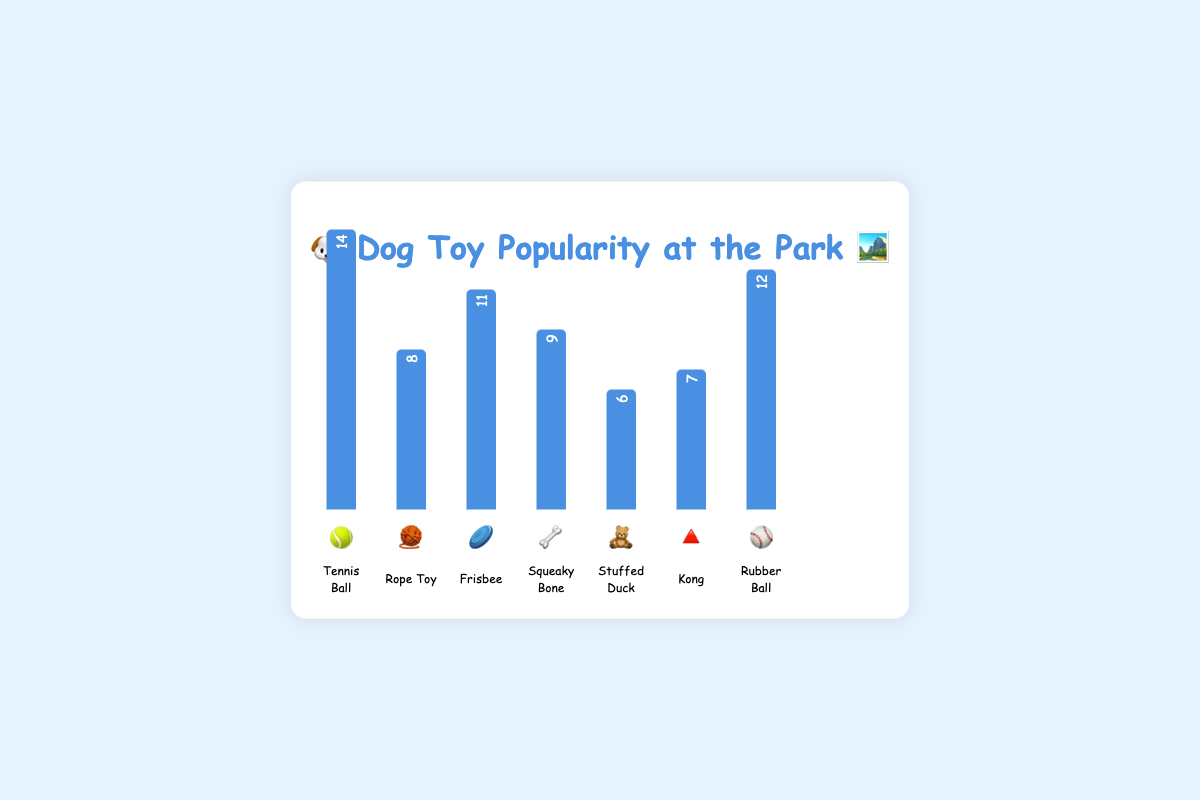What's the title of the chart? The title of the chart is mentioned at the top of the figure, styled prominently in Comic Sans MS font.
Answer: 🐶 Dog Toy Popularity at the Park 🏞️ Which toy is the most popular? The most popular toy is determined by the toy with the highest bar height and label value. The Tennis Ball has the highest count of 14.
Answer: Tennis Ball 🎾 How many Rubber Balls were brought to the park? Look at the height of the bar associated with the Rubber Ball and the label on the bar. The Rubber Ball has a count of 12.
Answer: 12 ⚾ Which toy has a higher count: Squeaky Bone or Kong? Compare the heights and the labels of the bars for Squeaky Bone and Kong. Squeaky Bone has a count of 9, and Kong has a count of 7.
Answer: Squeaky Bone 🦴 What is the combined count of the Rope Toy and Stuffed Duck? Add the counts of Rope Toy (8) and Stuffed Duck (6) to get the combined total.
Answer: 14 Rank the toys from the most popular to the least popular. Order the toys based on their counts from highest to lowest by examining each bar's height and label.
1. Tennis Ball (14)
2. Rubber Ball (12)
3. Frisbee (11)
4. Squeaky Bone (9)
5. Rope Toy (8)
6. Kong (7)
7. Stuffed Duck (6)
Answer: Tennis Ball 🎾, Rubber Ball ⚾, Frisbee 🥏, Squeaky Bone 🦴, Rope Toy 🧶, Kong 🔺, Stuffed Duck 🧸 What is the average number of toys for Rope Toy, Frisbee, and Kong? Add the counts of Rope Toy (8), Frisbee (11), and Kong (7) and then divide by the number of toys (3).
(8 + 11 + 7) / 3 = 8.67
Answer: 8.67 By how much does the count of Tennis Balls exceed Stuffed Ducks? Subtract the count of Stuffed Ducks (6) from the count of Tennis Balls (14).
14 - 6 = 8
Answer: 8 Which toy doesn't have an animal-specific emoji? Identify the toy that has an emoji not directly representing an animal. Kong uses a triangular emoji which is not animal-specific.
Answer: Kong 🔺 If you bring 3 more Rubber Balls, what will their new count be? Add the current count of Rubber Balls (12) to the number of additional Rubber Balls (3).
12 + 3 = 15
Answer: 15 